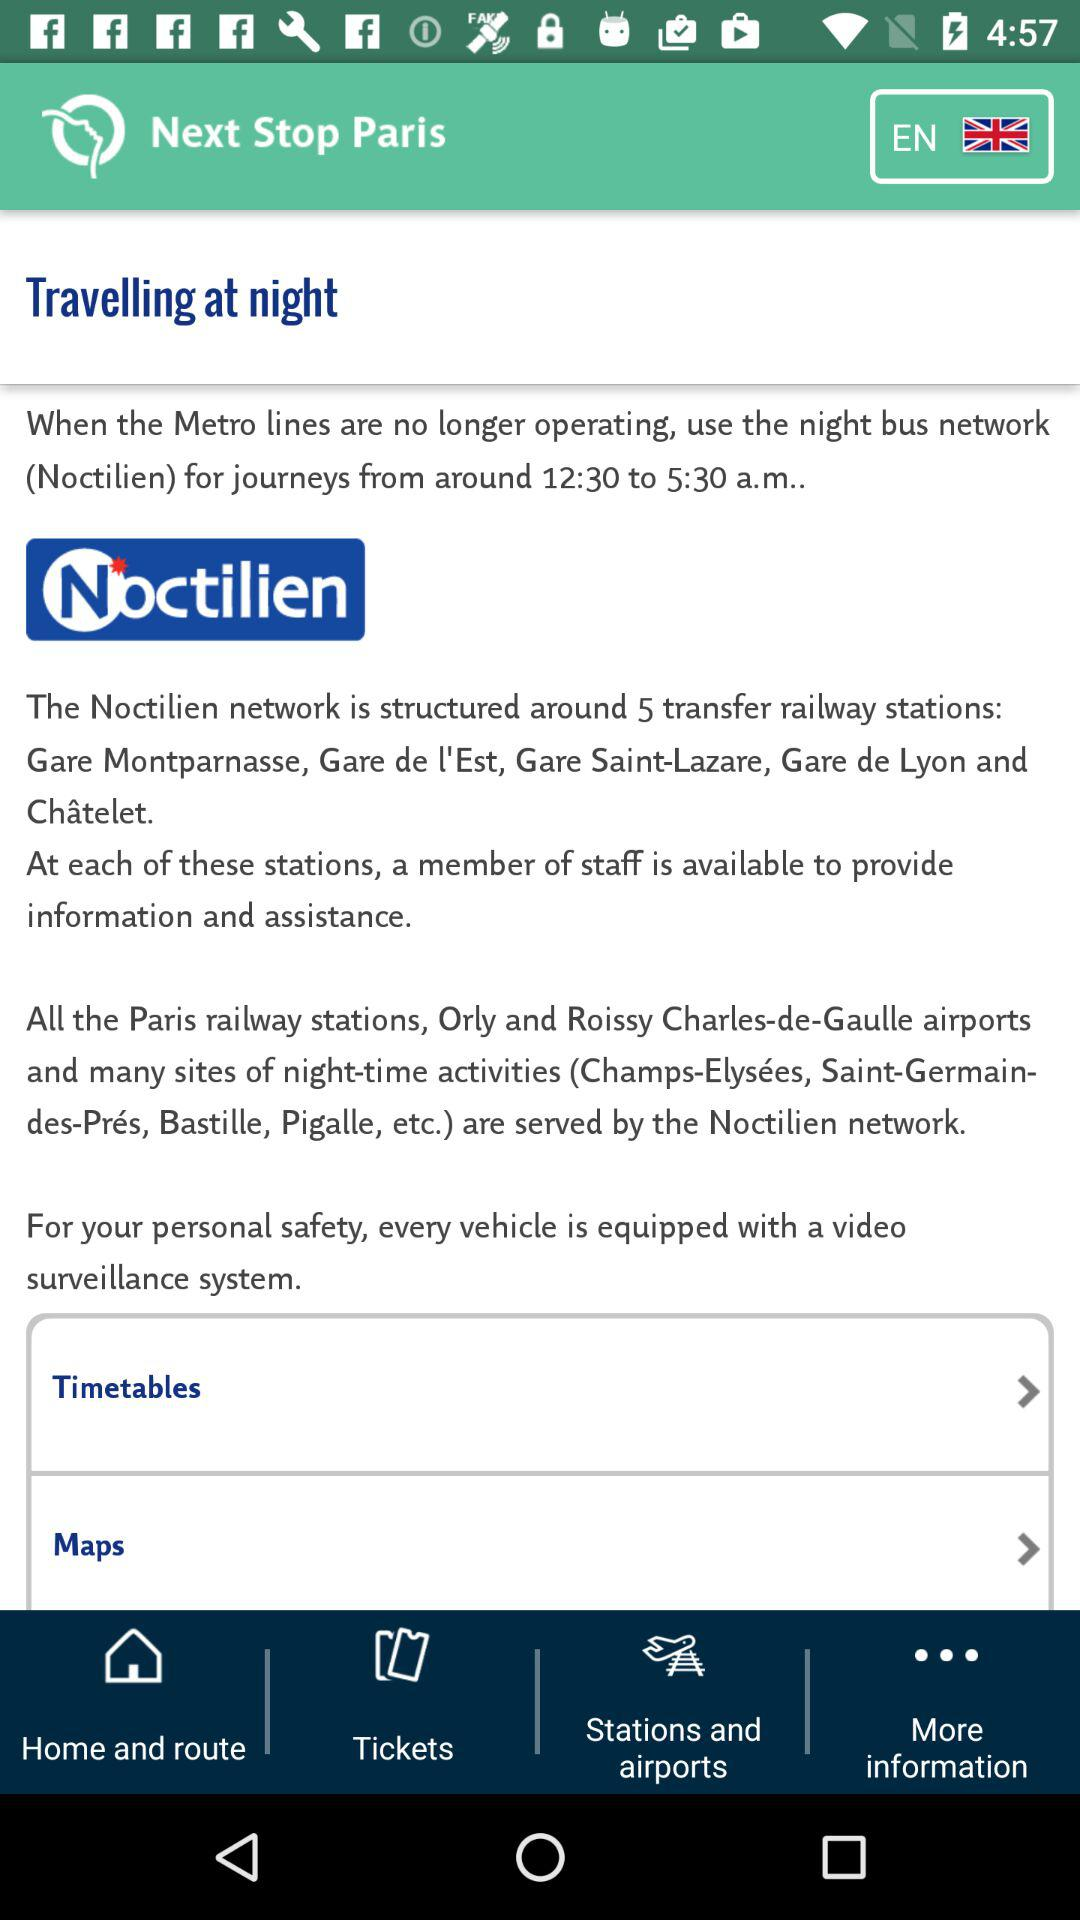What is the name of the night bus network? The name is Noctilien. 